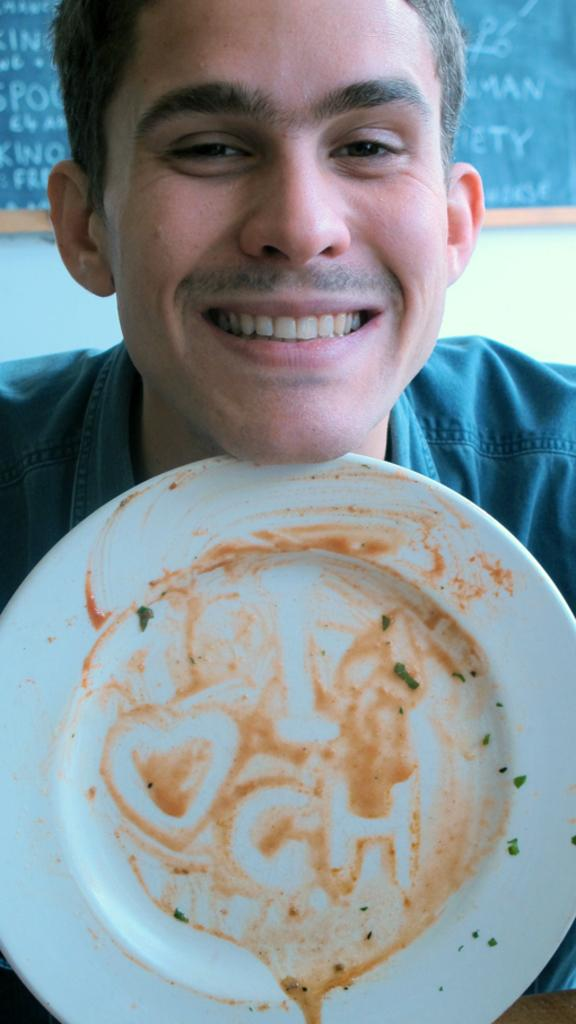What object can be seen on a surface in the image? There is a plate in the image. Who is present in the image? There is a man in the image. What is the man's facial expression? The man is smiling. What can be seen on the wall in the background of the image? There is a board on the wall in the background of the image. Can you see any wings on the man in the image? There are no wings visible on the man in the image. What type of structure is depicted on the board in the background? The board in the background does not show any structures; it is not detailed enough to determine its content. 